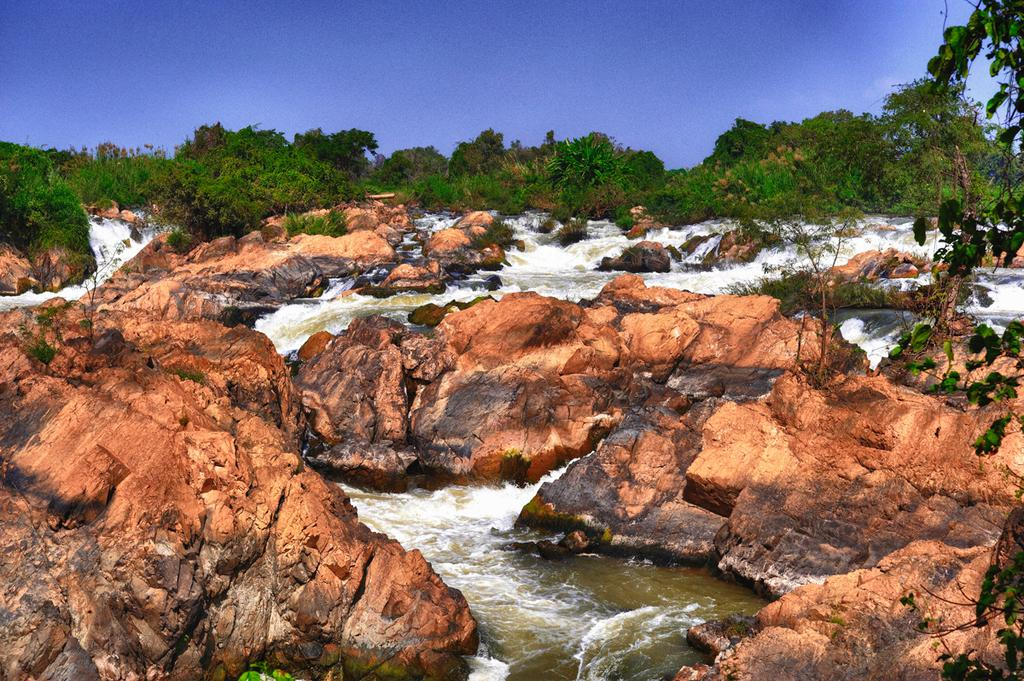What type of natural elements can be seen in the image? There are rocks, water, and trees visible in the image. Can you describe the water in the image? The water is visible in the image. What type of vegetation is present in the image? There are trees in the image. What type of rice is being cooked in the image? There is no rice present in the image; it features rocks, water, and trees. What type of border is visible in the image? There is no border visible in the image; it features rocks, water, and trees. 